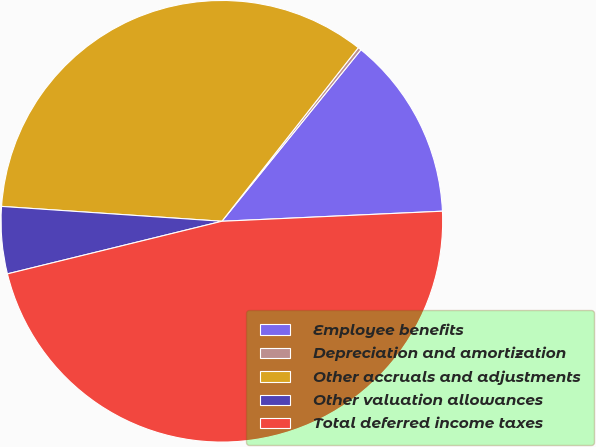Convert chart. <chart><loc_0><loc_0><loc_500><loc_500><pie_chart><fcel>Employee benefits<fcel>Depreciation and amortization<fcel>Other accruals and adjustments<fcel>Other valuation allowances<fcel>Total deferred income taxes<nl><fcel>13.43%<fcel>0.24%<fcel>34.53%<fcel>4.9%<fcel>46.9%<nl></chart> 